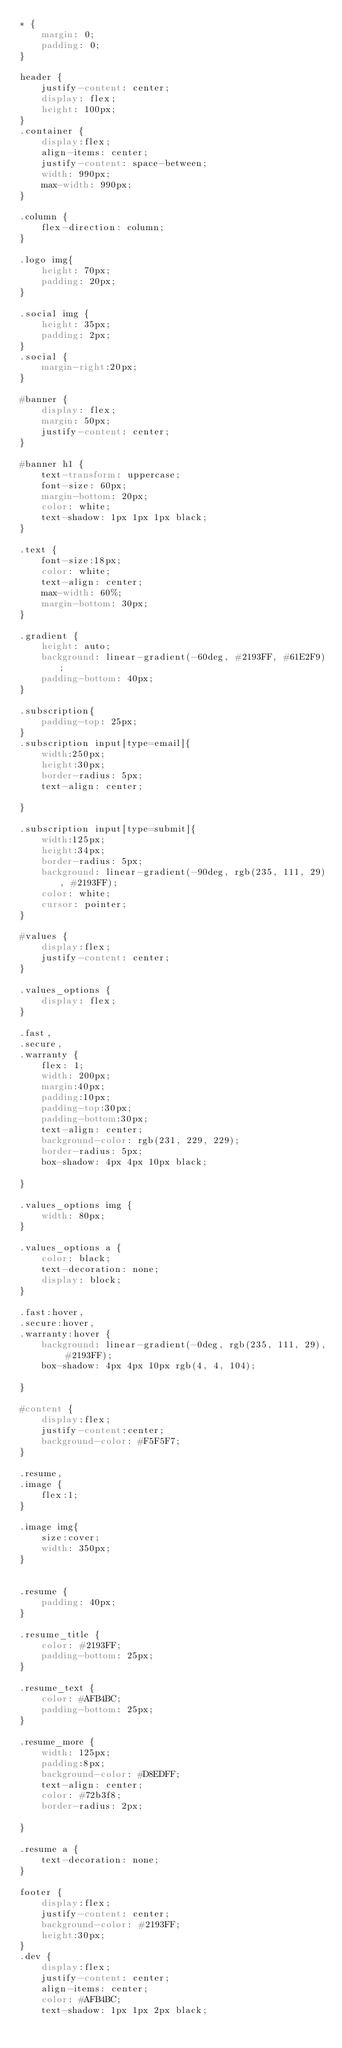<code> <loc_0><loc_0><loc_500><loc_500><_CSS_>* {
    margin: 0;
    padding: 0;
}

header {
    justify-content: center;
    display: flex;
    height: 100px;
}
.container {
    display:flex;
    align-items: center;
    justify-content: space-between;
    width: 990px;
    max-width: 990px;
}

.column {
    flex-direction: column;
}

.logo img{
    height: 70px;
    padding: 20px;
}

.social img {
    height: 35px;
    padding: 2px;
}
.social {
    margin-right:20px;
}

#banner {
    display: flex;
    margin: 50px;
    justify-content: center;
}

#banner h1 {
    text-transform: uppercase;
    font-size: 60px;
    margin-bottom: 20px;
    color: white;
    text-shadow: 1px 1px 1px black;
}

.text {
    font-size:18px;
    color: white;
    text-align: center;
    max-width: 60%;
    margin-bottom: 30px;
}

.gradient {
    height: auto;
    background: linear-gradient(-60deg, #2193FF, #61E2F9);
    padding-bottom: 40px;
}

.subscription{
    padding-top: 25px;
}
.subscription input[type=email]{
    width:250px;
    height:30px;
    border-radius: 5px;
    text-align: center;
    
}

.subscription input[type=submit]{
    width:125px;
    height:34px;
    border-radius: 5px;
    background: linear-gradient(-90deg, rgb(235, 111, 29), #2193FF);
    color: white;
    cursor: pointer;
}

#values {
    display:flex;
    justify-content: center;
}

.values_options {
    display: flex;
}

.fast,
.secure,
.warranty {
    flex: 1;
    width: 200px;
    margin:40px;
    padding:10px;
    padding-top:30px;
    padding-bottom:30px;
    text-align: center;
    background-color: rgb(231, 229, 229);
    border-radius: 5px;
    box-shadow: 4px 4px 10px black;

}

.values_options img {
    width: 80px;
}

.values_options a {
    color: black;
    text-decoration: none;
    display: block;
}

.fast:hover,
.secure:hover,
.warranty:hover {
    background: linear-gradient(-0deg, rgb(235, 111, 29), #2193FF);
    box-shadow: 4px 4px 10px rgb(4, 4, 104);
  
}

#content {
    display:flex;
    justify-content:center;
    background-color: #F5F5F7;
}

.resume,
.image {
    flex:1;
}

.image img{
    size:cover;
    width: 350px;
}


.resume {
    padding: 40px;
}

.resume_title {
    color: #2193FF;
    padding-bottom: 25px;
}

.resume_text {
    color: #AFB4BC;
    padding-bottom: 25px;
}

.resume_more {
    width: 125px;
    padding:8px;
    background-color: #D8EDFF;
    text-align: center;
    color: #72b3f8;
    border-radius: 2px;
    
}

.resume a {
    text-decoration: none;
}

footer {
    display:flex;
    justify-content: center;
    background-color: #2193FF;
    height:30px;
}
.dev {
    display:flex;
    justify-content: center;
    align-items: center;
    color: #AFB4BC;
    text-shadow: 1px 1px 2px black;</code> 